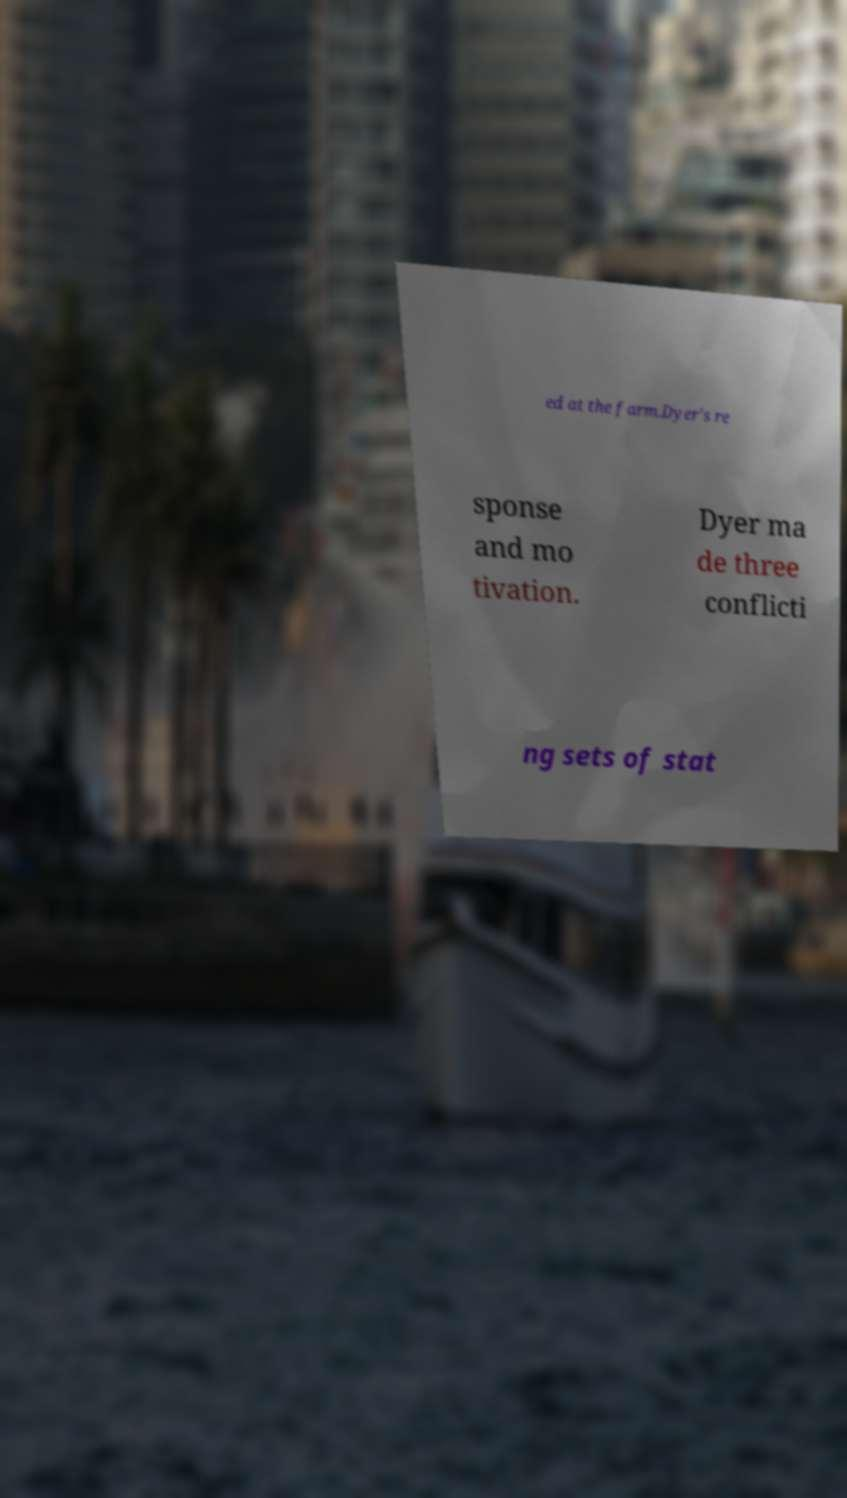I need the written content from this picture converted into text. Can you do that? ed at the farm.Dyer's re sponse and mo tivation. Dyer ma de three conflicti ng sets of stat 